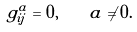Convert formula to latex. <formula><loc_0><loc_0><loc_500><loc_500>g ^ { a } _ { i j } = 0 , \quad a \neq 0 .</formula> 